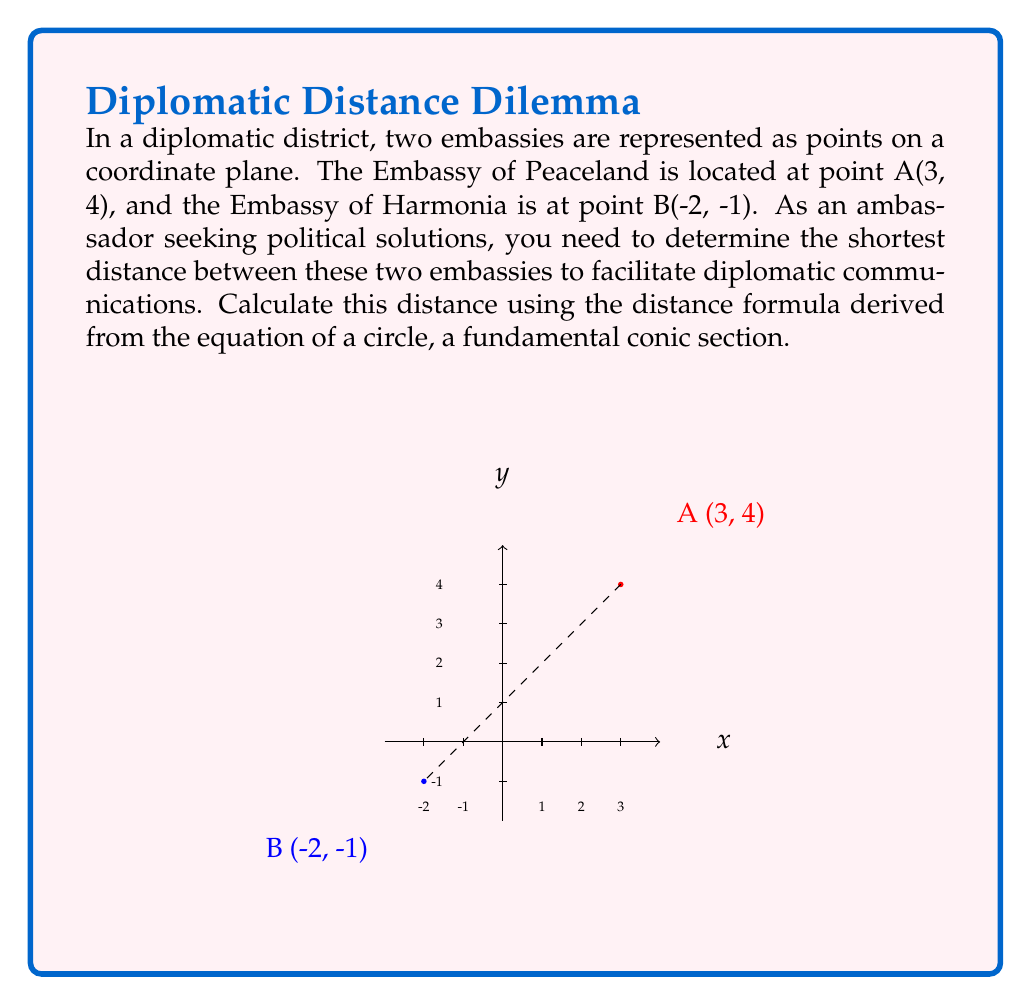Show me your answer to this math problem. To find the distance between two points on a coordinate plane, we use the distance formula, which is derived from the equation of a circle (a conic section). The distance formula is:

$$d = \sqrt{(x_2 - x_1)^2 + (y_2 - y_1)^2}$$

Where $(x_1, y_1)$ and $(x_2, y_2)$ are the coordinates of the two points.

Given:
- Embassy of Peaceland: A(3, 4)
- Embassy of Harmonia: B(-2, -1)

Let's solve this step-by-step:

1) Identify the coordinates:
   $(x_1, y_1) = (3, 4)$
   $(x_2, y_2) = (-2, -1)$

2) Substitute these values into the distance formula:
   $$d = \sqrt{(-2 - 3)^2 + (-1 - 4)^2}$$

3) Simplify inside the parentheses:
   $$d = \sqrt{(-5)^2 + (-5)^2}$$

4) Calculate the squares:
   $$d = \sqrt{25 + 25}$$

5) Add inside the square root:
   $$d = \sqrt{50}$$

6) Simplify the square root:
   $$d = 5\sqrt{2}$$

This distance, $5\sqrt{2}$ units, represents the shortest path between the two embassies, which is crucial for efficient diplomatic communications and fostering international cooperation.
Answer: $5\sqrt{2}$ units 